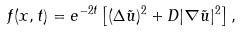Convert formula to latex. <formula><loc_0><loc_0><loc_500><loc_500>f ( x , t ) = e ^ { - 2 t } \left [ ( \Delta \tilde { u } ) ^ { 2 } + D | \nabla \tilde { u } | ^ { 2 } \right ] ,</formula> 